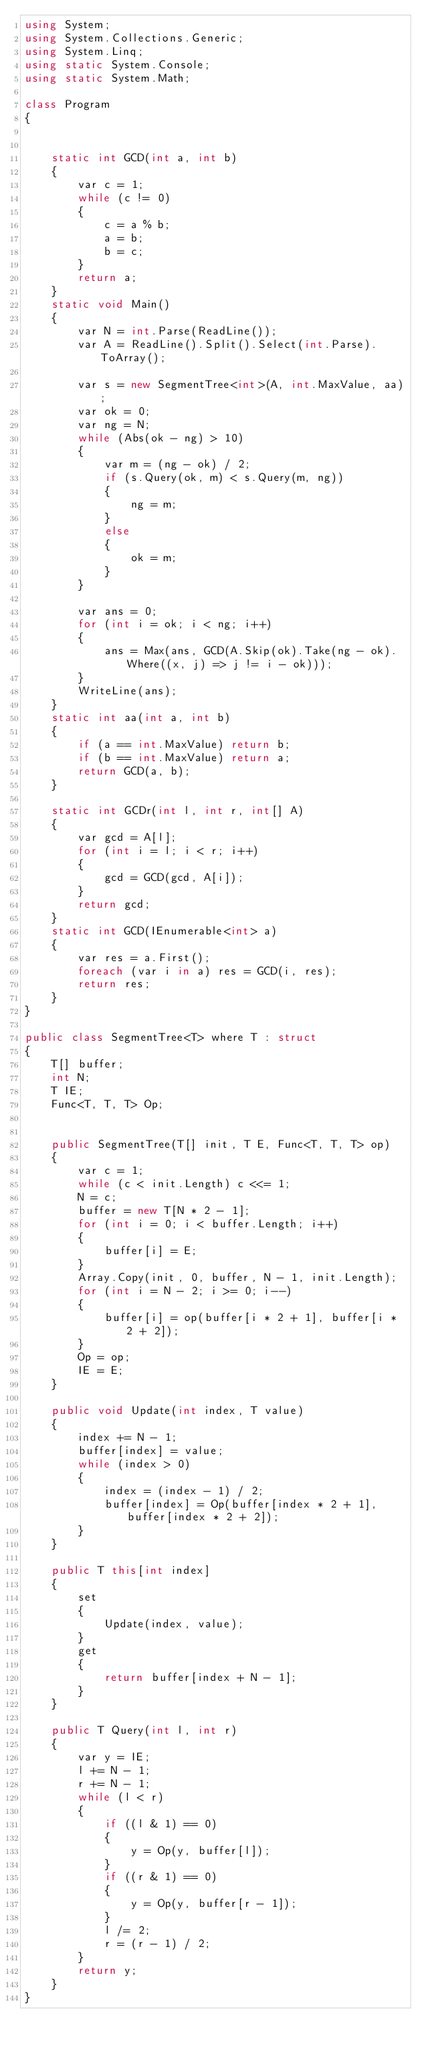<code> <loc_0><loc_0><loc_500><loc_500><_C#_>using System;
using System.Collections.Generic;
using System.Linq;
using static System.Console;
using static System.Math;
 
class Program
{


    static int GCD(int a, int b)
    {
        var c = 1;
        while (c != 0)
        {
            c = a % b;
            a = b;
            b = c;
        }
        return a;
    }
    static void Main()
    {
        var N = int.Parse(ReadLine());
        var A = ReadLine().Split().Select(int.Parse).ToArray();

        var s = new SegmentTree<int>(A, int.MaxValue, aa);
        var ok = 0;
        var ng = N;
        while (Abs(ok - ng) > 10)
        {
            var m = (ng - ok) / 2;
            if (s.Query(ok, m) < s.Query(m, ng))
            {
                ng = m;
            }
            else
            {
                ok = m;
            }
        }

        var ans = 0;
        for (int i = ok; i < ng; i++)
        {
            ans = Max(ans, GCD(A.Skip(ok).Take(ng - ok).Where((x, j) => j != i - ok)));
        }
        WriteLine(ans);
    }
    static int aa(int a, int b)
    {
        if (a == int.MaxValue) return b;
        if (b == int.MaxValue) return a;
        return GCD(a, b);
    }

    static int GCDr(int l, int r, int[] A)
    {
        var gcd = A[l];
        for (int i = l; i < r; i++)
        {
            gcd = GCD(gcd, A[i]);
        }
        return gcd;
    }
    static int GCD(IEnumerable<int> a)
    {
        var res = a.First();
        foreach (var i in a) res = GCD(i, res);
        return res;
    }
}

public class SegmentTree<T> where T : struct
{
    T[] buffer;
    int N;
    T IE;
    Func<T, T, T> Op;


    public SegmentTree(T[] init, T E, Func<T, T, T> op)
    {
        var c = 1;
        while (c < init.Length) c <<= 1;
        N = c;
        buffer = new T[N * 2 - 1];
        for (int i = 0; i < buffer.Length; i++)
        {
            buffer[i] = E;
        }
        Array.Copy(init, 0, buffer, N - 1, init.Length);
        for (int i = N - 2; i >= 0; i--)
        {
            buffer[i] = op(buffer[i * 2 + 1], buffer[i * 2 + 2]);
        }
        Op = op;
        IE = E;
    }

    public void Update(int index, T value)
    {
        index += N - 1;
        buffer[index] = value;
        while (index > 0)
        {
            index = (index - 1) / 2;
            buffer[index] = Op(buffer[index * 2 + 1], buffer[index * 2 + 2]);
        }
    }

    public T this[int index]
    {
        set
        {
            Update(index, value);
        }
        get
        {
            return buffer[index + N - 1];
        }
    }

    public T Query(int l, int r)
    {
        var y = IE;
        l += N - 1;
        r += N - 1;
        while (l < r)
        {
            if ((l & 1) == 0)
            {
                y = Op(y, buffer[l]);
            }
            if ((r & 1) == 0)
            {
                y = Op(y, buffer[r - 1]);
            }
            l /= 2;
            r = (r - 1) / 2;
        }
        return y;
    }
}</code> 